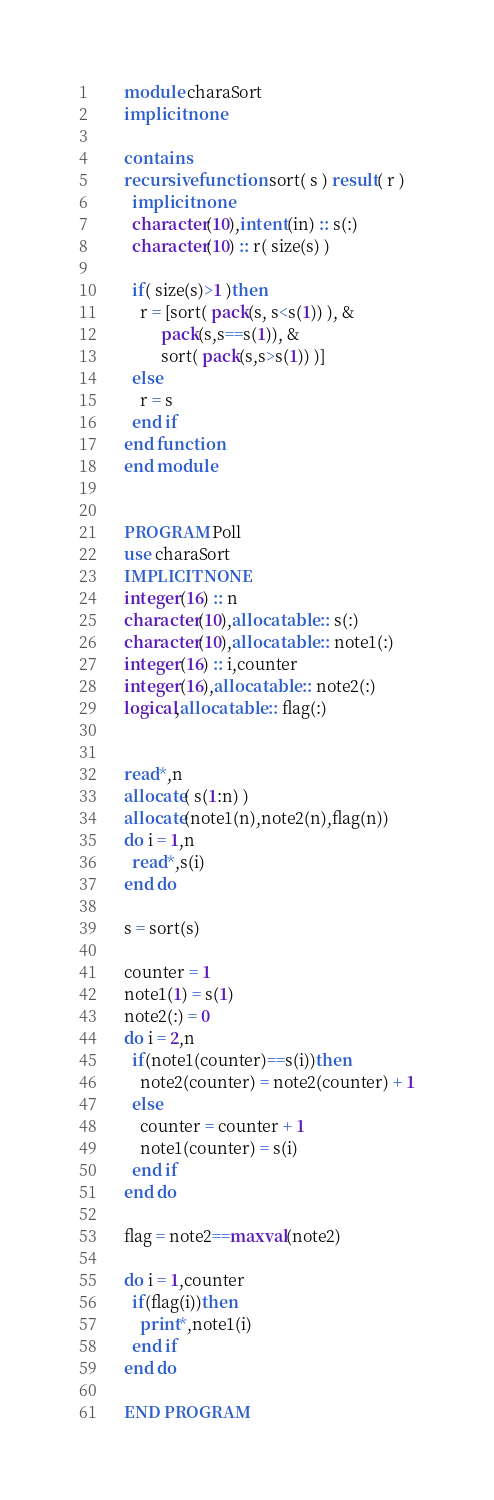Convert code to text. <code><loc_0><loc_0><loc_500><loc_500><_FORTRAN_>      module charaSort
      implicit none
      
      contains
      recursive function sort( s ) result( r )
        implicit none
        character(10),intent(in) :: s(:)
        character(10) :: r( size(s) )
        
        if( size(s)>1 )then
          r = [sort( pack(s, s<s(1)) ), &
               pack(s,s==s(1)), &
               sort( pack(s,s>s(1)) )]
        else
          r = s
        end if
      end function
      end module


      PROGRAM Poll
      use charaSort
      IMPLICIT NONE
      integer(16) :: n
      character(10),allocatable :: s(:)
      character(10),allocatable :: note1(:)
      integer(16) :: i,counter
      integer(16),allocatable :: note2(:)
      logical,allocatable :: flag(:)
      
      
      read*,n
      allocate( s(1:n) )
      allocate(note1(n),note2(n),flag(n))
      do i = 1,n
        read*,s(i)
      end do
      
      s = sort(s)
      
      counter = 1
      note1(1) = s(1)
      note2(:) = 0
      do i = 2,n
        if(note1(counter)==s(i))then
          note2(counter) = note2(counter) + 1
        else
          counter = counter + 1
          note1(counter) = s(i)
        end if
      end do
      
      flag = note2==maxval(note2)
      
      do i = 1,counter
        if(flag(i))then
          print*,note1(i)
        end if
      end do
      
      END PROGRAM</code> 